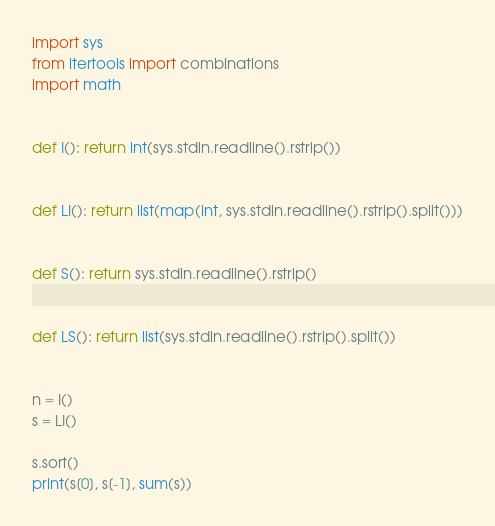Convert code to text. <code><loc_0><loc_0><loc_500><loc_500><_Python_>import sys
from itertools import combinations
import math


def I(): return int(sys.stdin.readline().rstrip())


def LI(): return list(map(int, sys.stdin.readline().rstrip().split()))


def S(): return sys.stdin.readline().rstrip()


def LS(): return list(sys.stdin.readline().rstrip().split())


n = I()
s = LI()

s.sort()
print(s[0], s[-1], sum(s))

</code> 